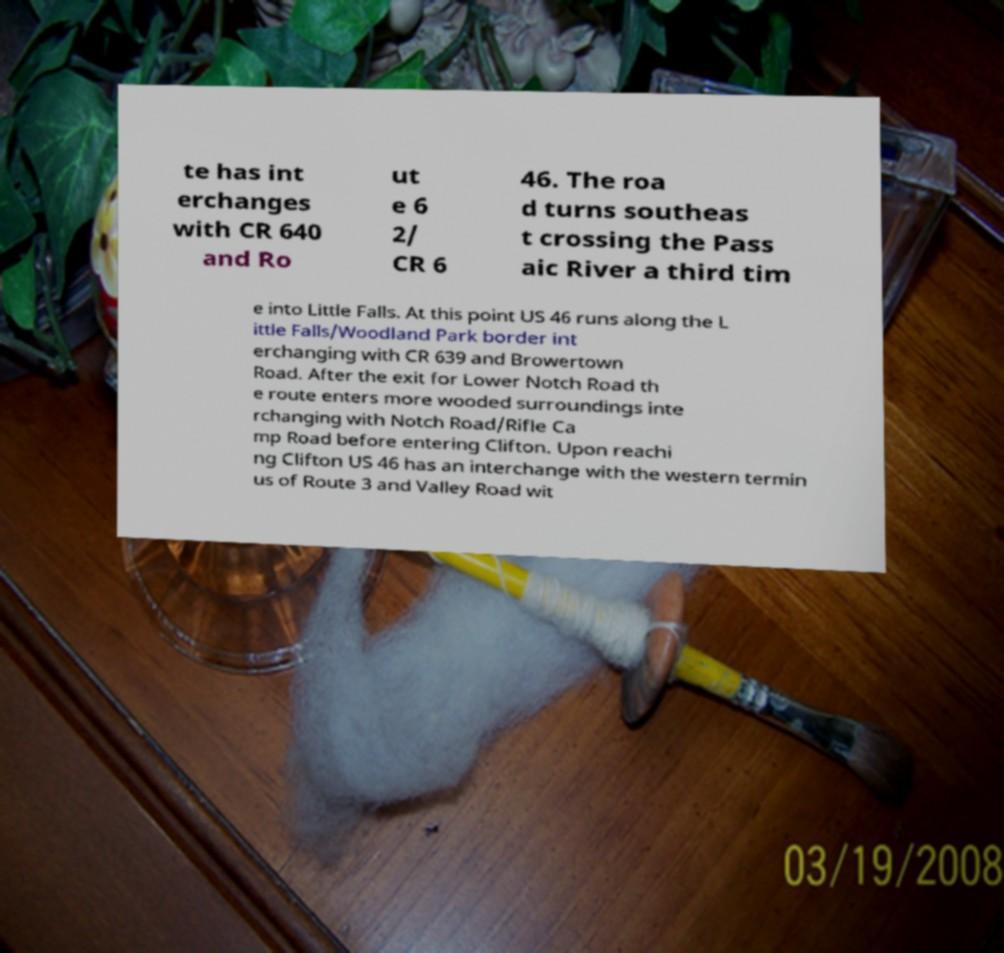There's text embedded in this image that I need extracted. Can you transcribe it verbatim? te has int erchanges with CR 640 and Ro ut e 6 2/ CR 6 46. The roa d turns southeas t crossing the Pass aic River a third tim e into Little Falls. At this point US 46 runs along the L ittle Falls/Woodland Park border int erchanging with CR 639 and Browertown Road. After the exit for Lower Notch Road th e route enters more wooded surroundings inte rchanging with Notch Road/Rifle Ca mp Road before entering Clifton. Upon reachi ng Clifton US 46 has an interchange with the western termin us of Route 3 and Valley Road wit 